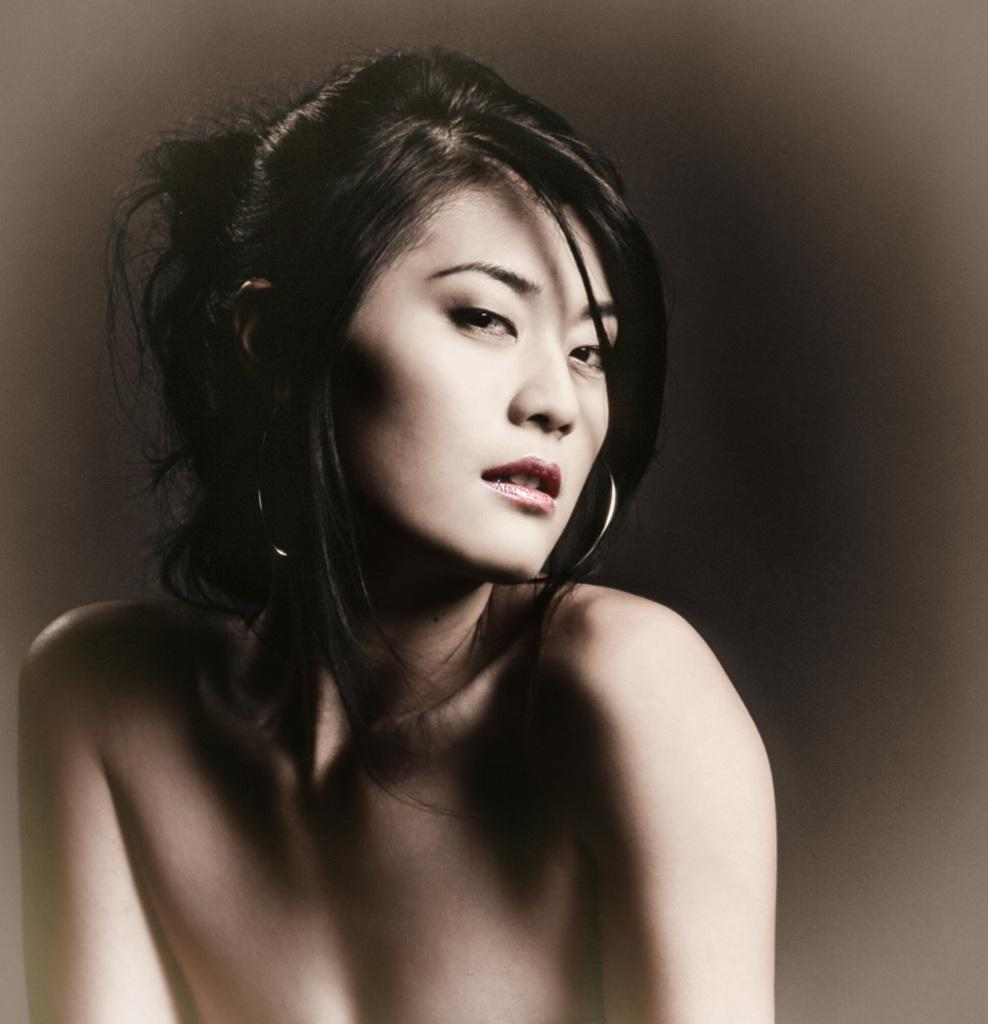Who is the main subject in the image? There is a girl in the image. What is the girl doing in the image? The girl is posing for the camera. What type of pear is the girl holding in the image? There is no pear present in the image; the girl is posing for the camera. 